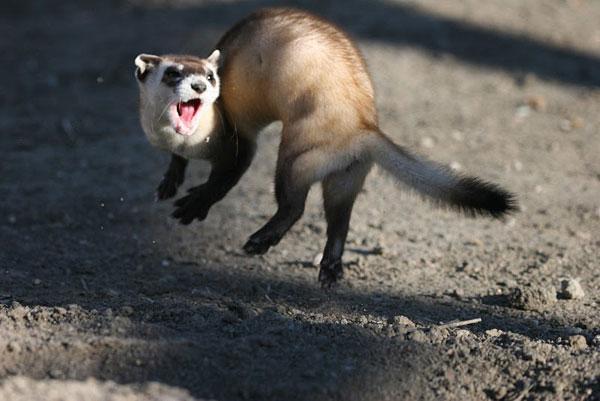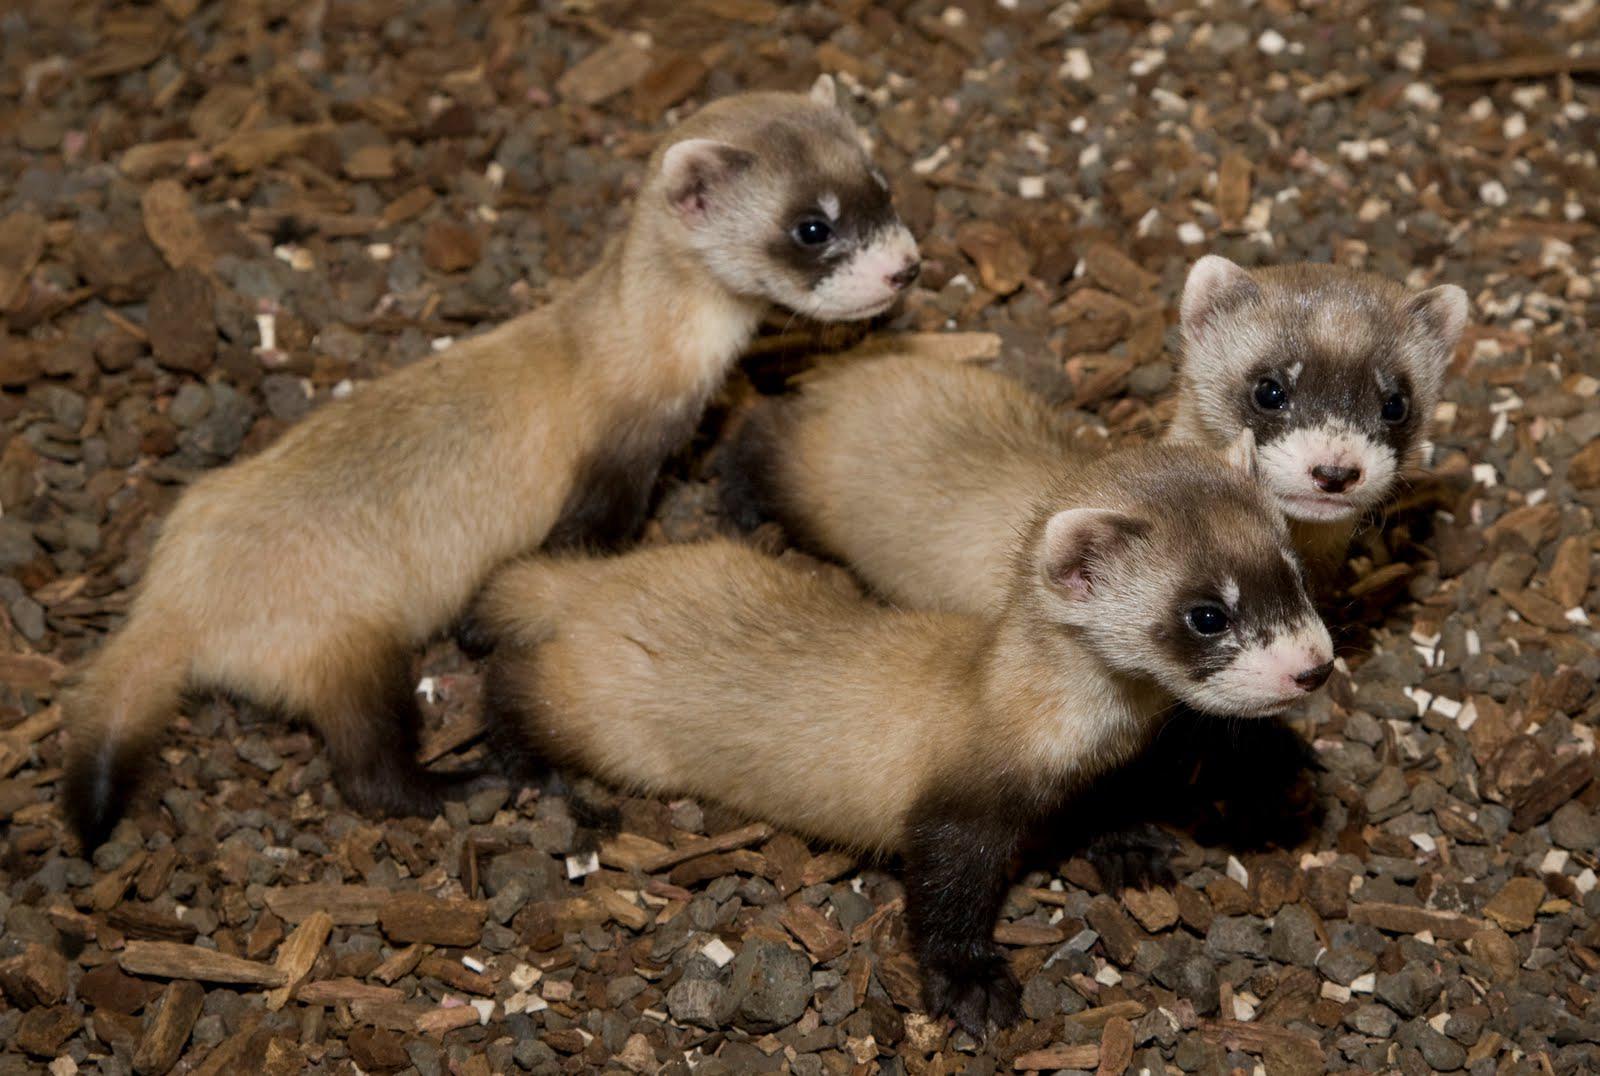The first image is the image on the left, the second image is the image on the right. Assess this claim about the two images: "There are no more than 3 ferrets shown.". Correct or not? Answer yes or no. No. 